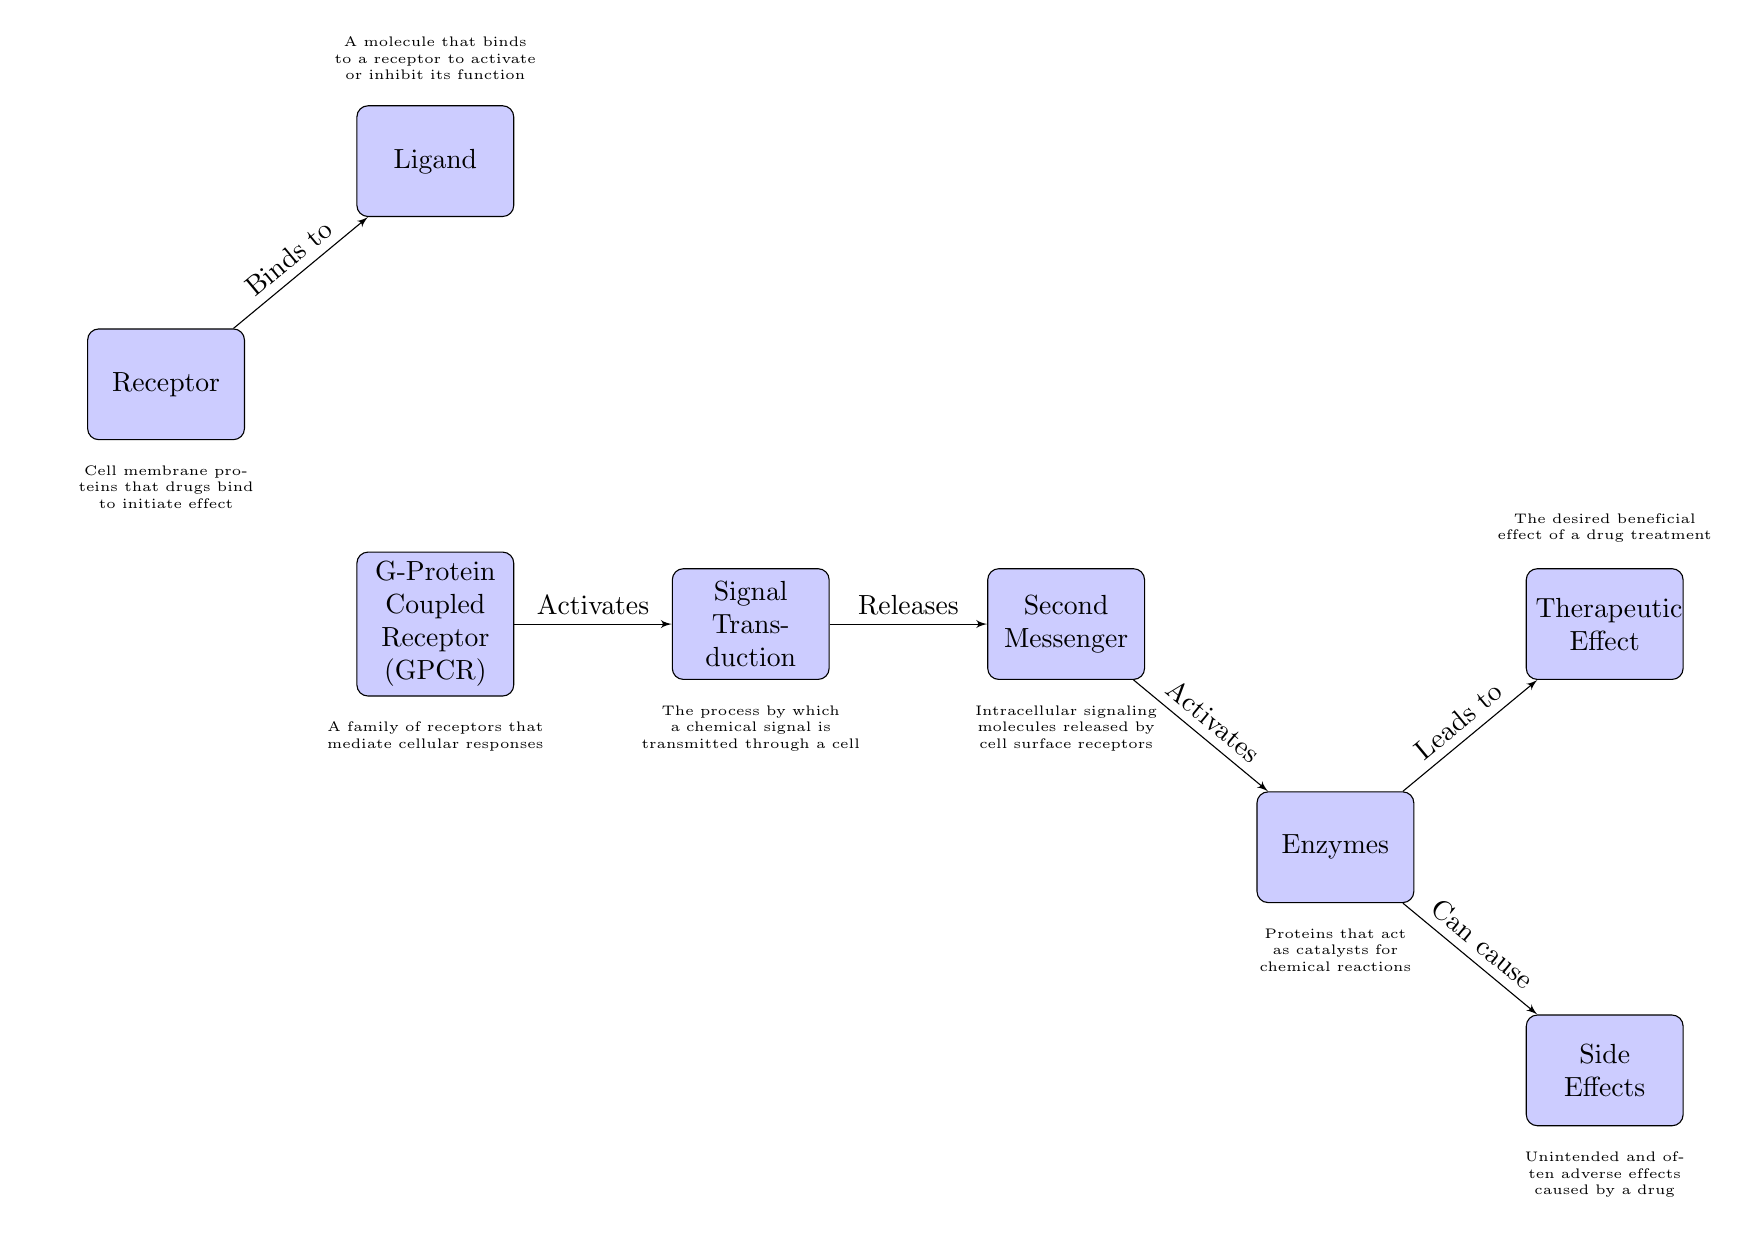What is the first node in the diagram? The first node in the diagram is labeled "Receptor," which is positioned at the top left of the diagram. This identifies the starting point of the drug action pathway.
Answer: Receptor How many blocks are present in the diagram? The diagram contains seven blocks, which includes "Receptor," "G-Protein Coupled Receptor (GPCR)," "Ligand," "Signal Transduction," "Second Messenger," "Enzymes," "Therapeutic Effect," and "Side Effects."
Answer: 7 What does the ligand do in the mechanism? The ligand binds to the receptor, initiating the process displayed in the diagram. This interaction is the starting point of the drug's mechanism of action.
Answer: Binds to Which block indicates the unwanted effects of a drug? The block labeled "Side Effects" indicates the unwanted effects caused by a drug, showing a potential outcome of the drug interaction with enzymes.
Answer: Side Effects What is released during signal transduction? During signal transduction, "Second Messenger" is released, which continues the flow of information in the diagram and activates further processes in the cellular response.
Answer: Second Messenger How does the signal transduction relate to the GPCR? The signal transduction is activated by the GPCR, which mediates the cellular responses upon activation by the ligand, establishing a connection between those two components.
Answer: Activates What leads to the therapeutic effect? The "Enzymes" block leads to the "Therapeutic Effect" block, indicating that the activation of enzymes results in the desired beneficial effects of drug treatment.
Answer: Leads to What role does the second messenger play in the pathway? The second messenger activates enzymes, playing a critical role in propagating the signal initiated by the ligand-receptor interaction, and is essential for producing downstream effects.
Answer: Activates What can occur as a result of the enzyme activity? The activity of enzymes can lead to both the therapeutic effect and side effects, thereby indicating the dual outcomes that can arise from the enzymatic reactions triggered by drug action.
Answer: Can cause 